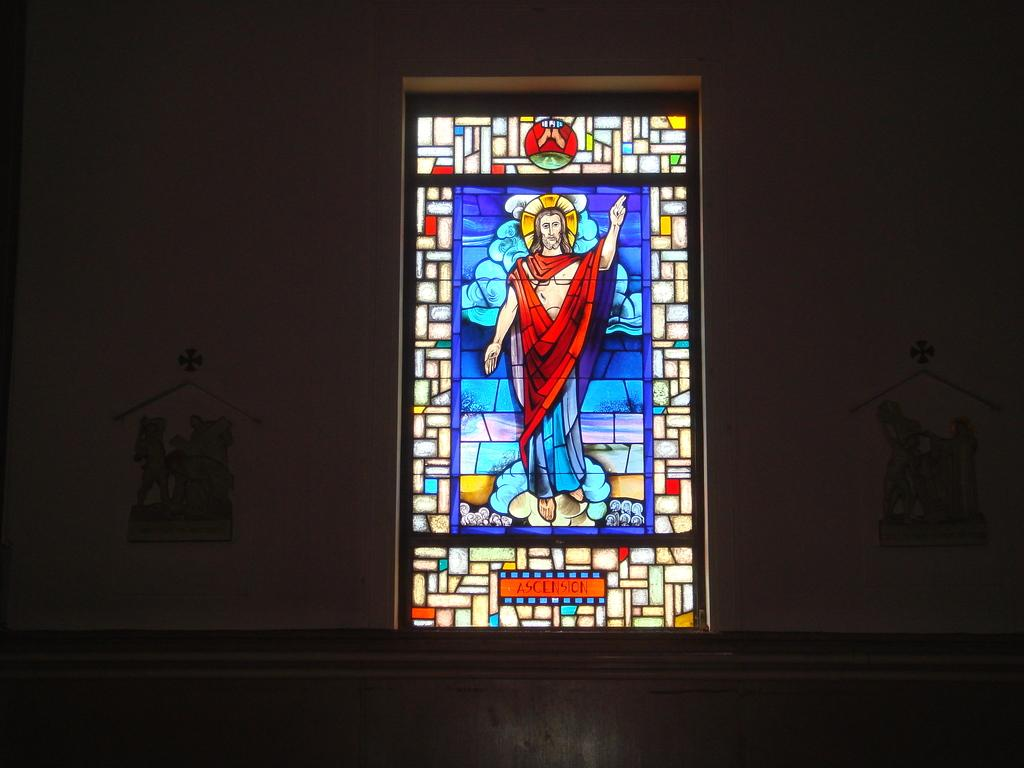What can be seen in the image that provides a view of the outside? There is a window in the image. What is the man in the image doing? The man is painting on the window. Where is the man painting located? The man painting is on the wall. What type of day is it in the image? The provided facts do not mention the weather or time of day, so it is impossible to determine the type of day in the image. Is the man painting the father of the person looking at the image? The provided facts do not mention any relationships between the man painting and other individuals, so it is impossible to determine if he is the father of the person looking at the image. 